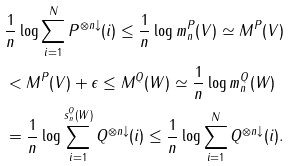<formula> <loc_0><loc_0><loc_500><loc_500>& \frac { 1 } { n } \log \sum _ { i = 1 } ^ { N } P ^ { \otimes n \downarrow } ( i ) \leq \frac { 1 } { n } \log m _ { n } ^ { P } ( V ) \simeq M ^ { P } ( V ) \\ & < M ^ { P } ( V ) + \epsilon \leq M ^ { Q } ( W ) \simeq \frac { 1 } { n } \log m _ { n } ^ { Q } ( W ) \\ & = \frac { 1 } { n } \log \sum _ { i = 1 } ^ { s _ { n } ^ { Q } ( W ) } Q ^ { \otimes n \downarrow } ( i ) \leq \frac { 1 } { n } \log \sum _ { i = 1 } ^ { N } Q ^ { \otimes n \downarrow } ( i ) .</formula> 